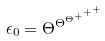Convert formula to latex. <formula><loc_0><loc_0><loc_500><loc_500>\epsilon _ { 0 } = \Theta ^ { \Theta ^ { \Theta ^ { + ^ { + ^ { + } } } } }</formula> 